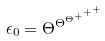Convert formula to latex. <formula><loc_0><loc_0><loc_500><loc_500>\epsilon _ { 0 } = \Theta ^ { \Theta ^ { \Theta ^ { + ^ { + ^ { + } } } } }</formula> 